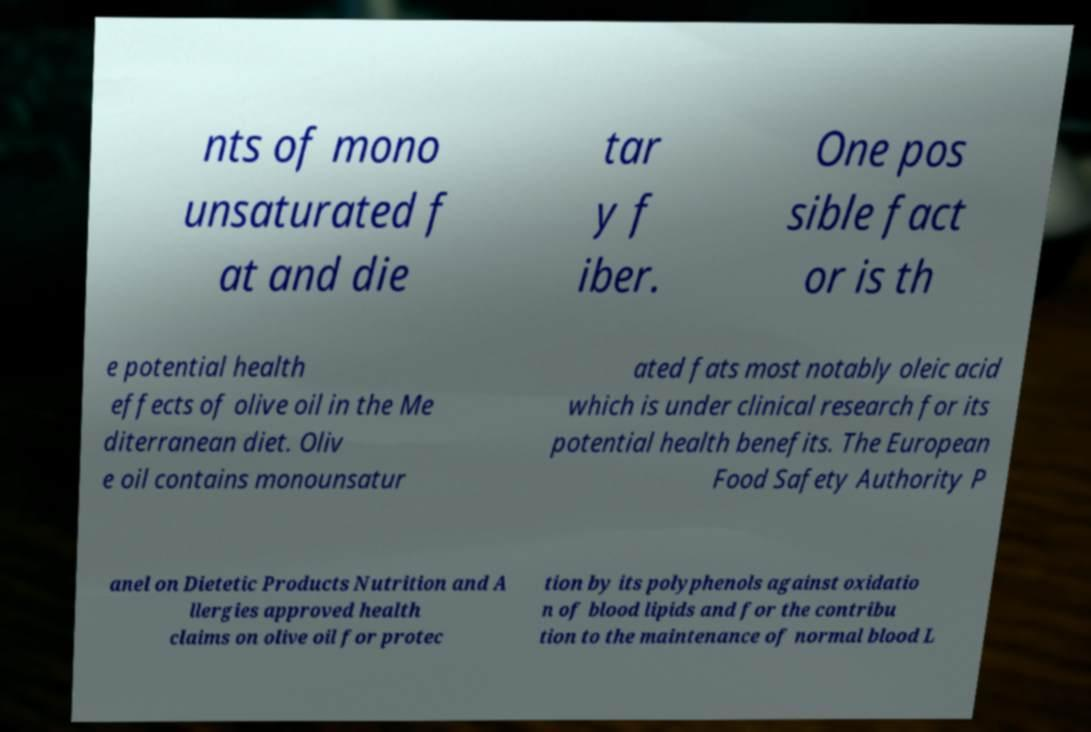Please identify and transcribe the text found in this image. nts of mono unsaturated f at and die tar y f iber. One pos sible fact or is th e potential health effects of olive oil in the Me diterranean diet. Oliv e oil contains monounsatur ated fats most notably oleic acid which is under clinical research for its potential health benefits. The European Food Safety Authority P anel on Dietetic Products Nutrition and A llergies approved health claims on olive oil for protec tion by its polyphenols against oxidatio n of blood lipids and for the contribu tion to the maintenance of normal blood L 